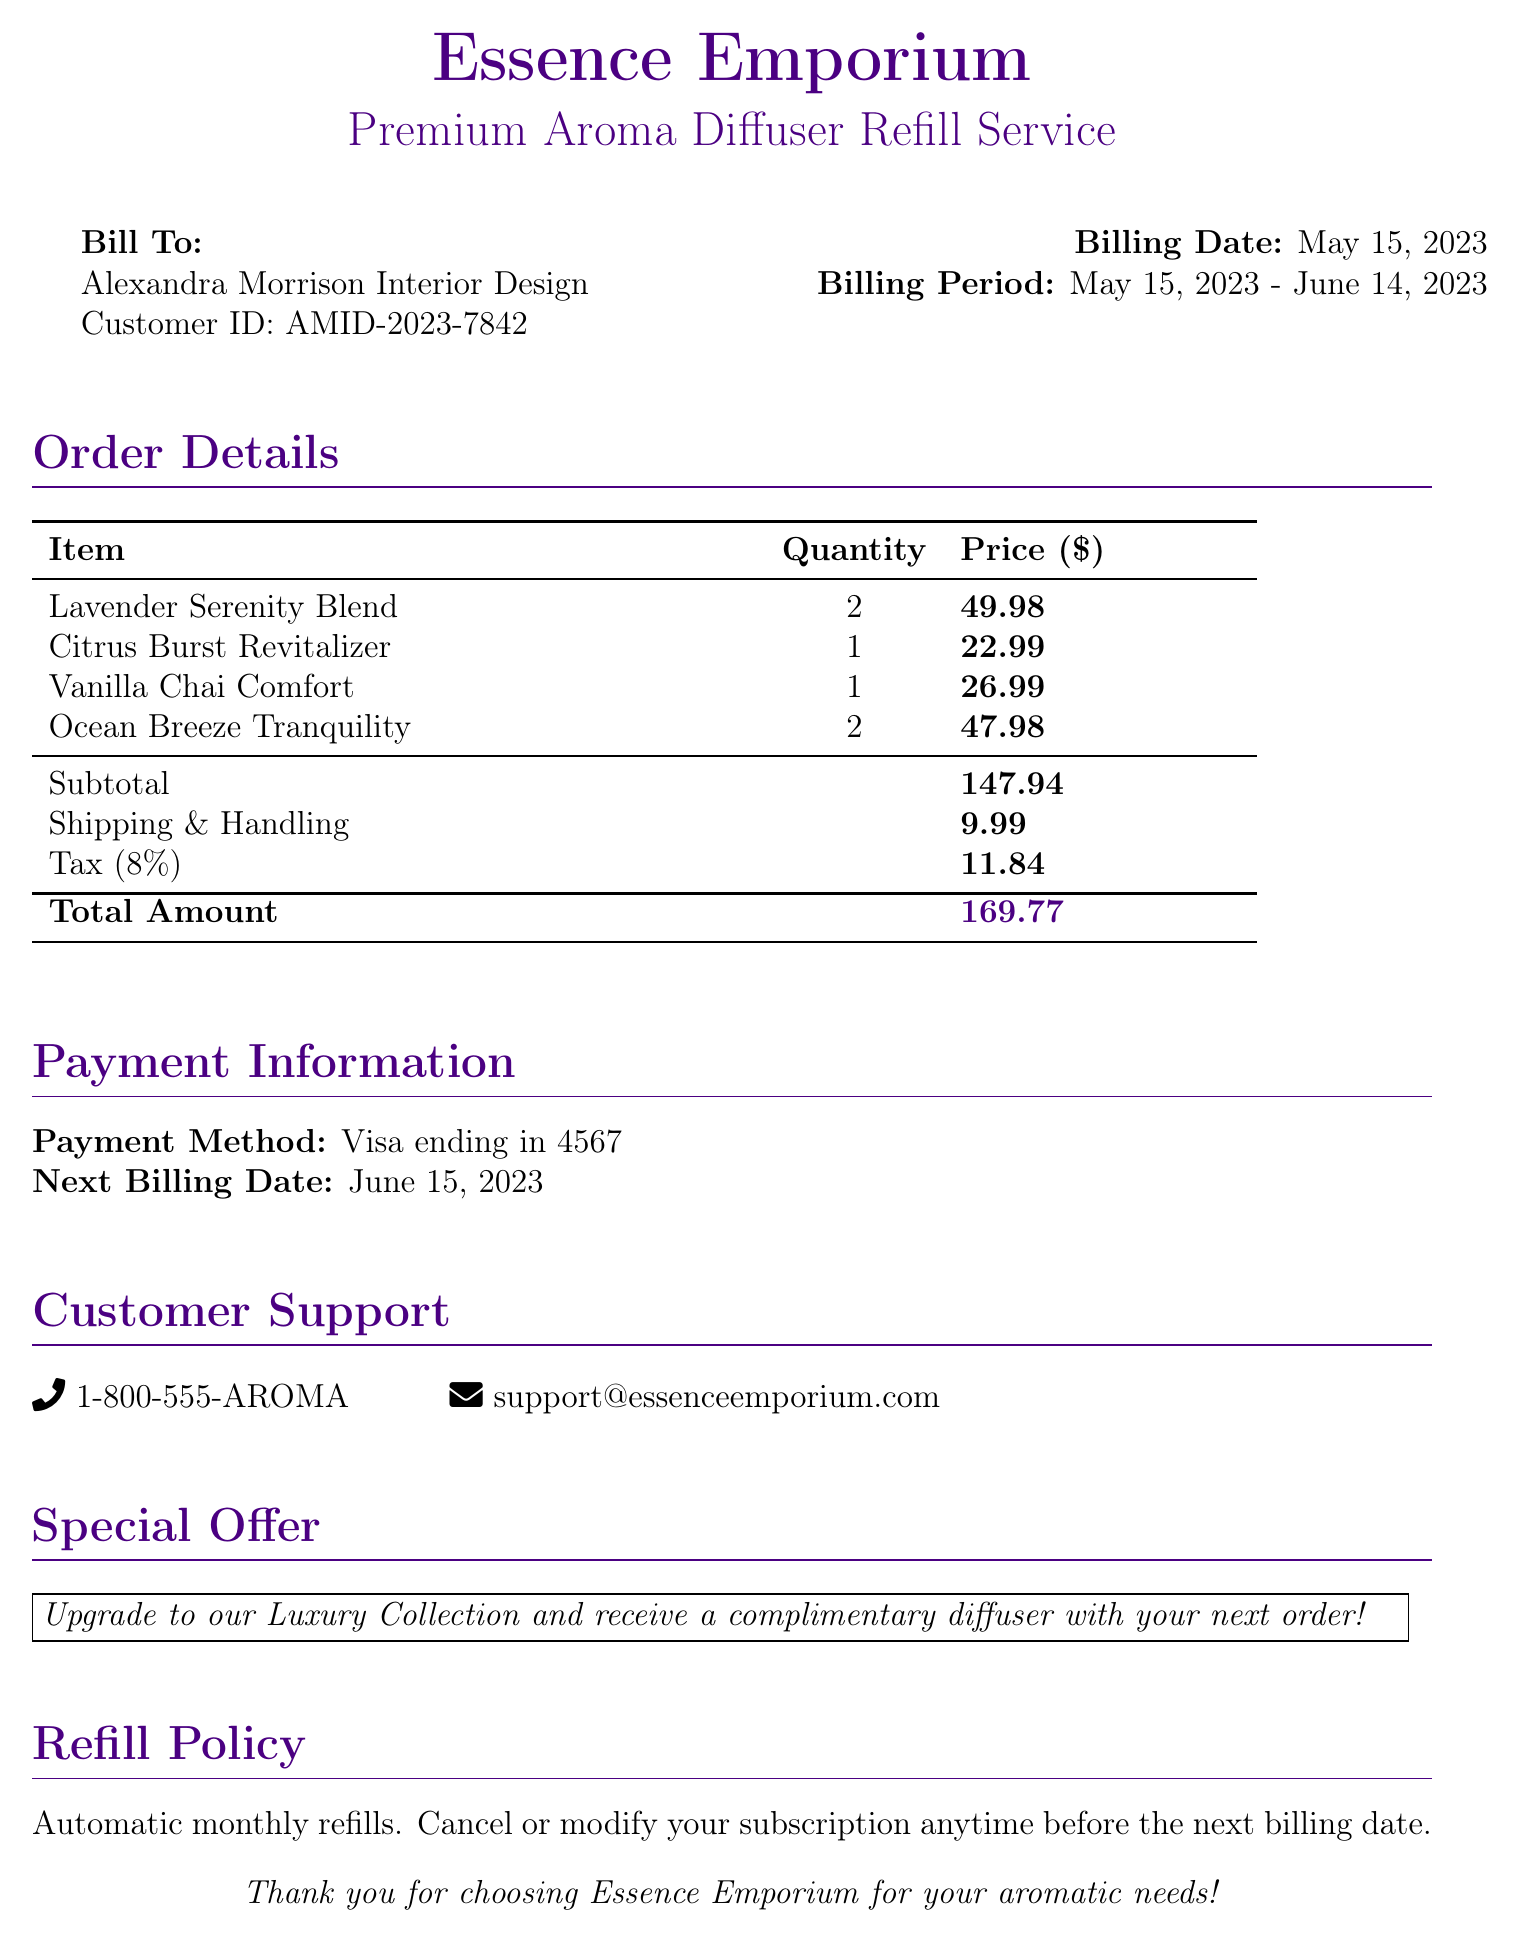What is the customer ID? The customer ID is a unique identifier for the service, listed in the bill.
Answer: AMID-2023-7842 What is the billing date? The billing date specifies when this bill is issued, found in the upper section of the document.
Answer: May 15, 2023 How many items of the Lavender Serenity Blend were ordered? This question asks for the quantity of a specific item, as detailed in the order section.
Answer: 2 What is the subtotal amount? The subtotal is the total before adding shipping and tax, indicated towards the end of the order details.
Answer: 147.94 What is the total amount due? The total amount due is the final amount, including all charges as shown in the summary section of the bill.
Answer: 169.77 What is the tax rate applied? The tax rate is provided in the breakdown of charges, indicating how tax is calculated.
Answer: 8% When is the next billing date? This date shows when the next charge will take place and is specified in the payment information.
Answer: June 15, 2023 What is the payment method used? This information reveals how the bill is to be paid, noted in the payment section.
Answer: Visa ending in 4567 What is the phone number for customer support? The customer support number provides a way to contact the company for assistance, detailed at the bottom of the document.
Answer: 1-800-555-AROMA 